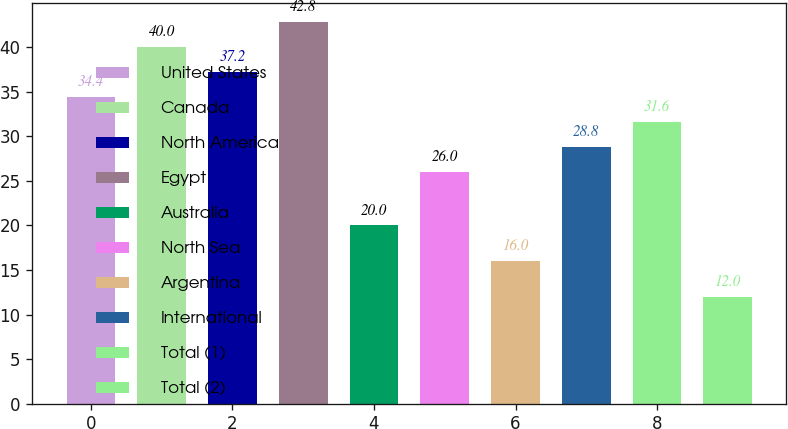Convert chart to OTSL. <chart><loc_0><loc_0><loc_500><loc_500><bar_chart><fcel>United States<fcel>Canada<fcel>North America<fcel>Egypt<fcel>Australia<fcel>North Sea<fcel>Argentina<fcel>International<fcel>Total (1)<fcel>Total (2)<nl><fcel>34.4<fcel>40<fcel>37.2<fcel>42.8<fcel>20<fcel>26<fcel>16<fcel>28.8<fcel>31.6<fcel>12<nl></chart> 